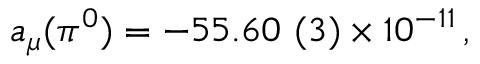<formula> <loc_0><loc_0><loc_500><loc_500>a _ { \mu } ( \pi ^ { 0 } ) = - 5 5 . 6 0 ( 3 ) \times 1 0 ^ { - 1 1 } \, ,</formula> 